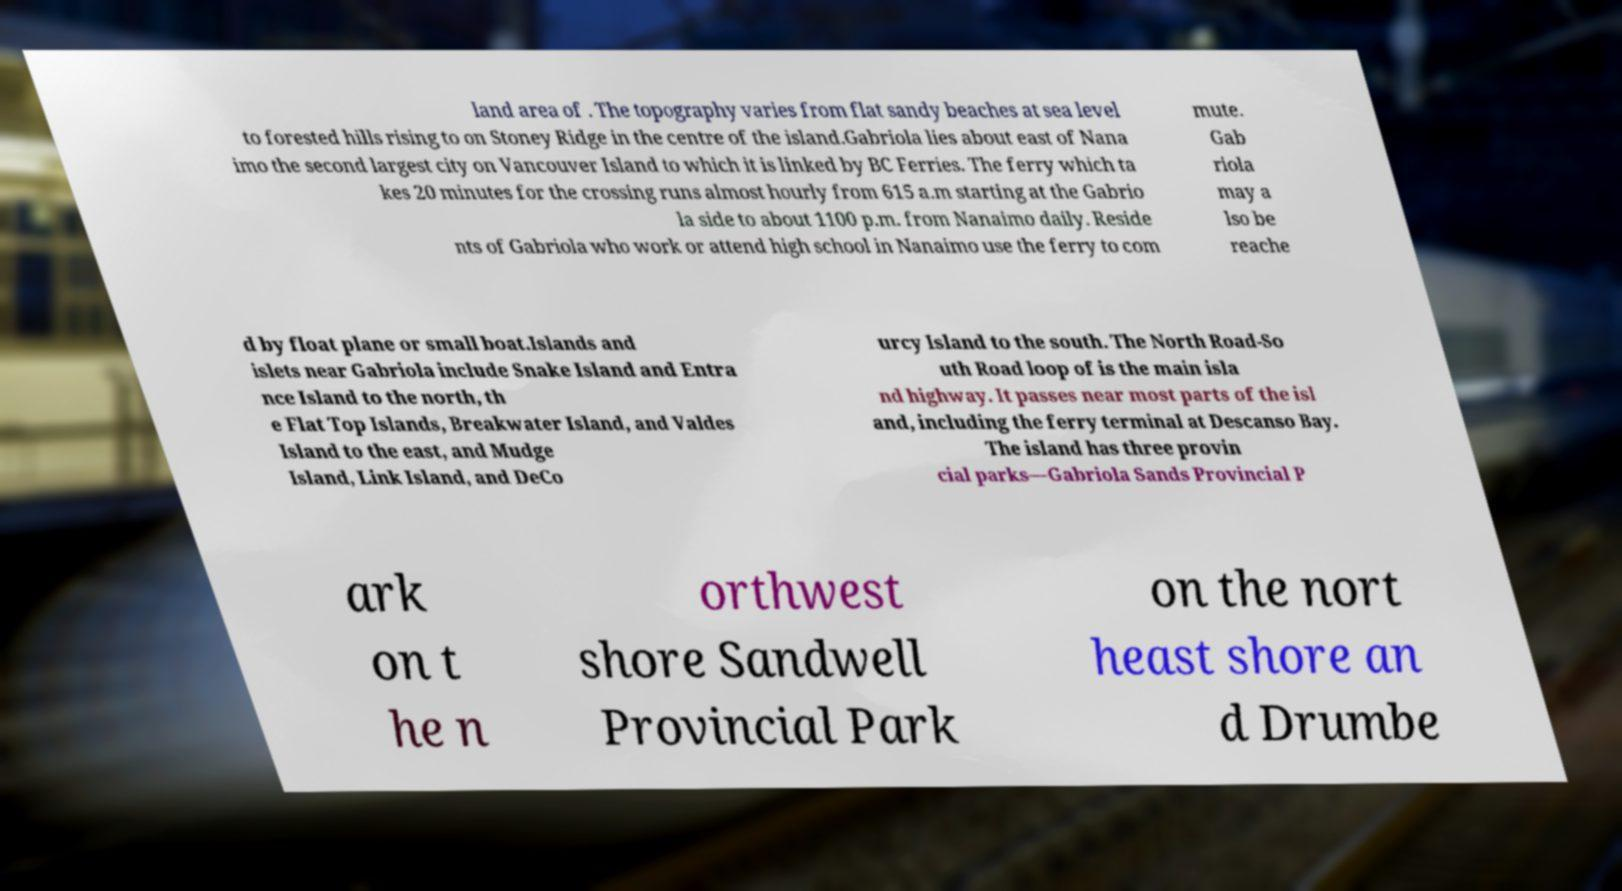I need the written content from this picture converted into text. Can you do that? land area of . The topography varies from flat sandy beaches at sea level to forested hills rising to on Stoney Ridge in the centre of the island.Gabriola lies about east of Nana imo the second largest city on Vancouver Island to which it is linked by BC Ferries. The ferry which ta kes 20 minutes for the crossing runs almost hourly from 615 a.m starting at the Gabrio la side to about 1100 p.m. from Nanaimo daily. Reside nts of Gabriola who work or attend high school in Nanaimo use the ferry to com mute. Gab riola may a lso be reache d by float plane or small boat.Islands and islets near Gabriola include Snake Island and Entra nce Island to the north, th e Flat Top Islands, Breakwater Island, and Valdes Island to the east, and Mudge Island, Link Island, and DeCo urcy Island to the south. The North Road-So uth Road loop of is the main isla nd highway. It passes near most parts of the isl and, including the ferry terminal at Descanso Bay. The island has three provin cial parks—Gabriola Sands Provincial P ark on t he n orthwest shore Sandwell Provincial Park on the nort heast shore an d Drumbe 